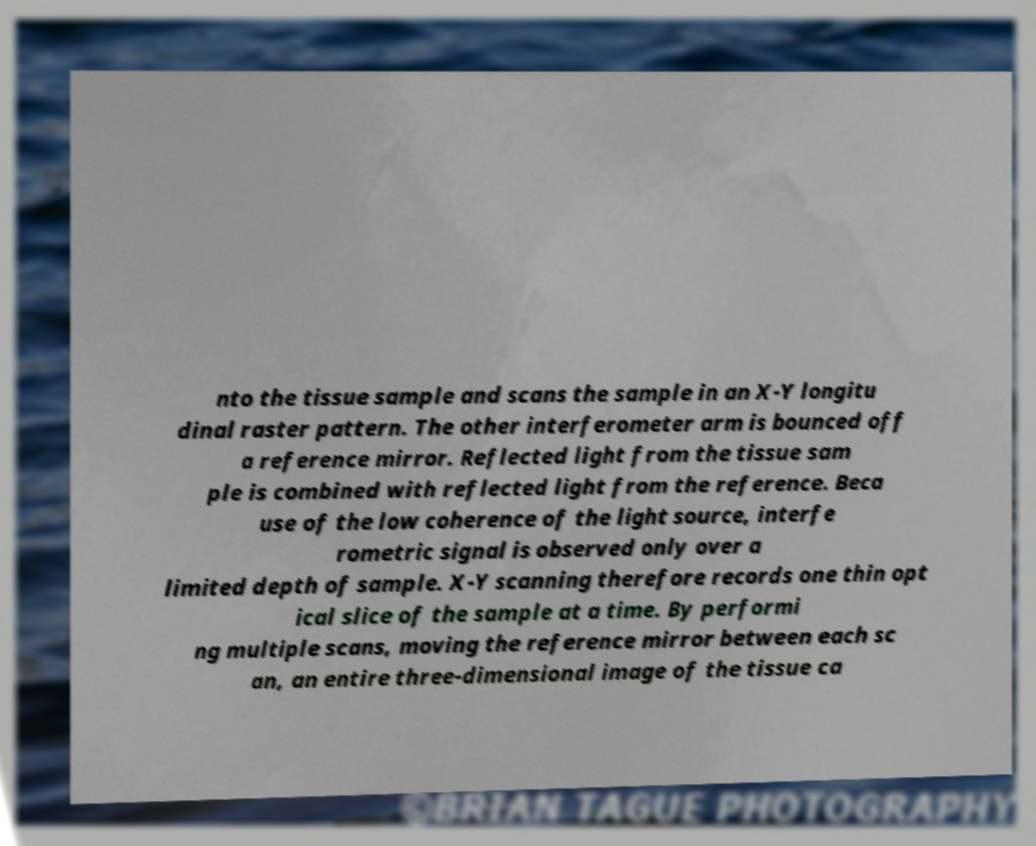For documentation purposes, I need the text within this image transcribed. Could you provide that? nto the tissue sample and scans the sample in an X-Y longitu dinal raster pattern. The other interferometer arm is bounced off a reference mirror. Reflected light from the tissue sam ple is combined with reflected light from the reference. Beca use of the low coherence of the light source, interfe rometric signal is observed only over a limited depth of sample. X-Y scanning therefore records one thin opt ical slice of the sample at a time. By performi ng multiple scans, moving the reference mirror between each sc an, an entire three-dimensional image of the tissue ca 